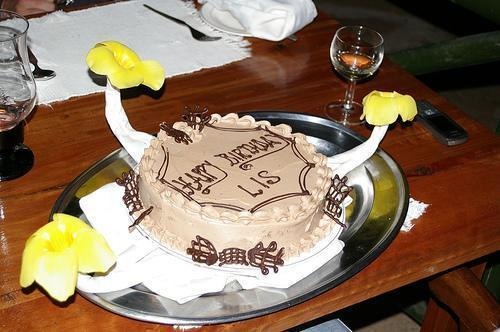How many cake on the table?
Give a very brief answer. 1. How many cats are licking the cake?
Give a very brief answer. 0. 